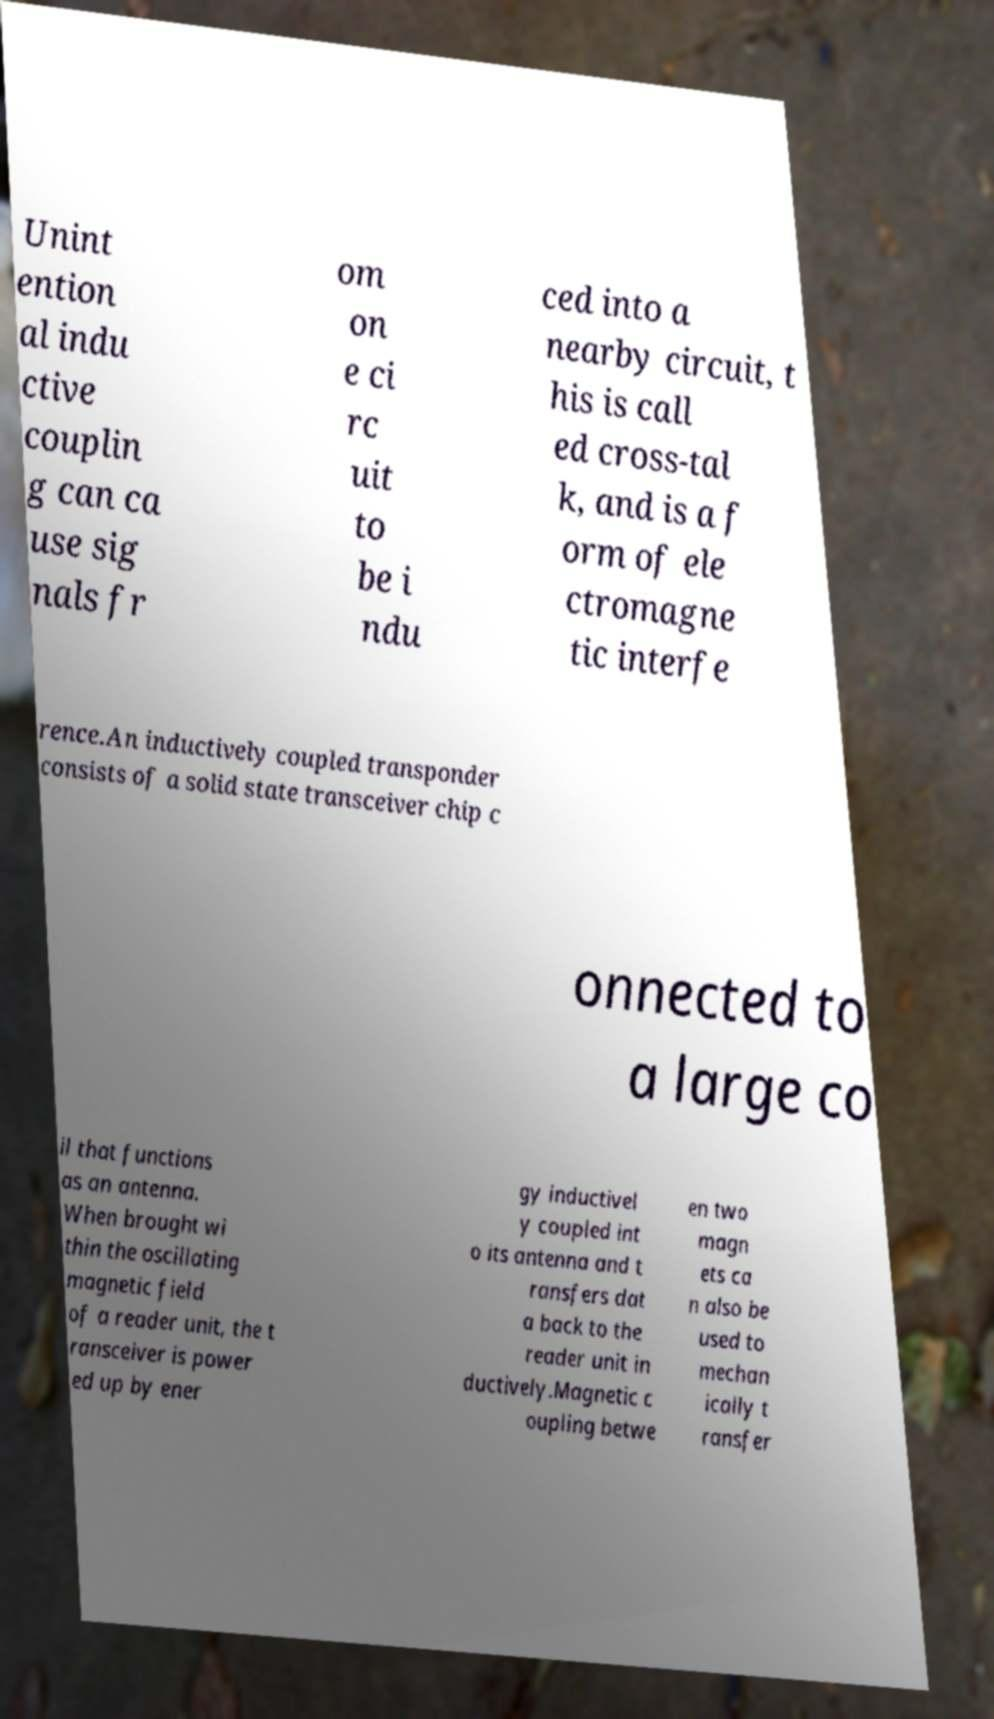Please read and relay the text visible in this image. What does it say? Unint ention al indu ctive couplin g can ca use sig nals fr om on e ci rc uit to be i ndu ced into a nearby circuit, t his is call ed cross-tal k, and is a f orm of ele ctromagne tic interfe rence.An inductively coupled transponder consists of a solid state transceiver chip c onnected to a large co il that functions as an antenna. When brought wi thin the oscillating magnetic field of a reader unit, the t ransceiver is power ed up by ener gy inductivel y coupled int o its antenna and t ransfers dat a back to the reader unit in ductively.Magnetic c oupling betwe en two magn ets ca n also be used to mechan ically t ransfer 